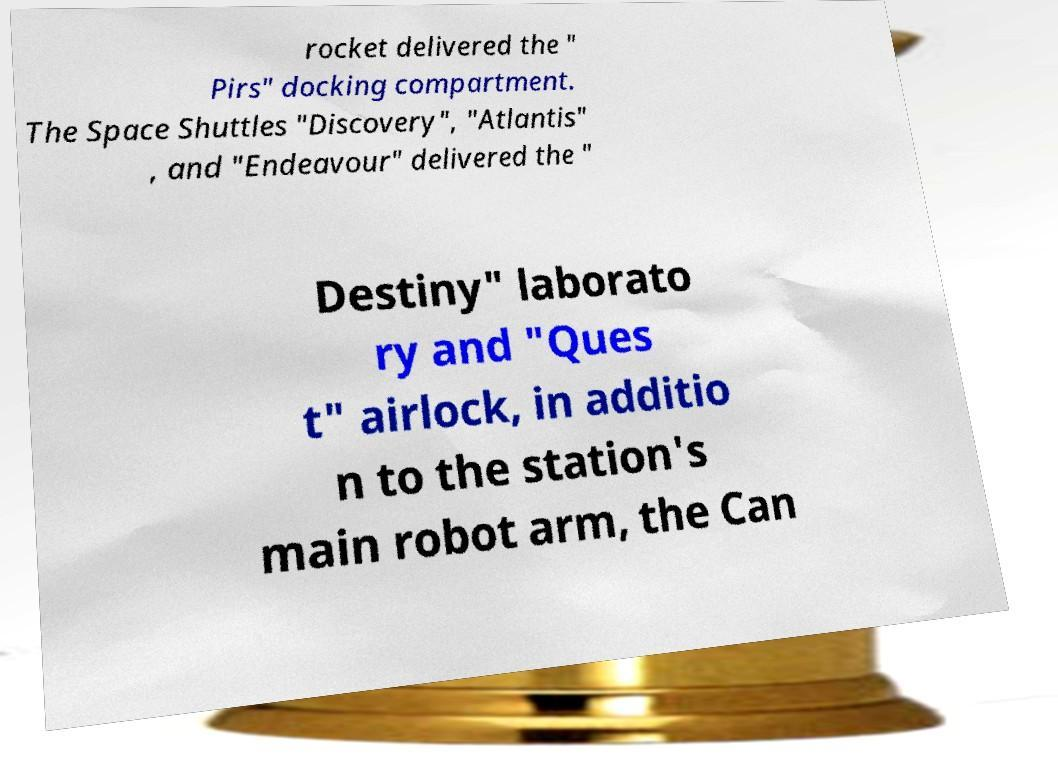There's text embedded in this image that I need extracted. Can you transcribe it verbatim? rocket delivered the " Pirs" docking compartment. The Space Shuttles "Discovery", "Atlantis" , and "Endeavour" delivered the " Destiny" laborato ry and "Ques t" airlock, in additio n to the station's main robot arm, the Can 